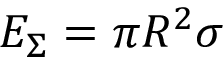Convert formula to latex. <formula><loc_0><loc_0><loc_500><loc_500>E _ { \Sigma } = \pi R ^ { 2 } \sigma</formula> 